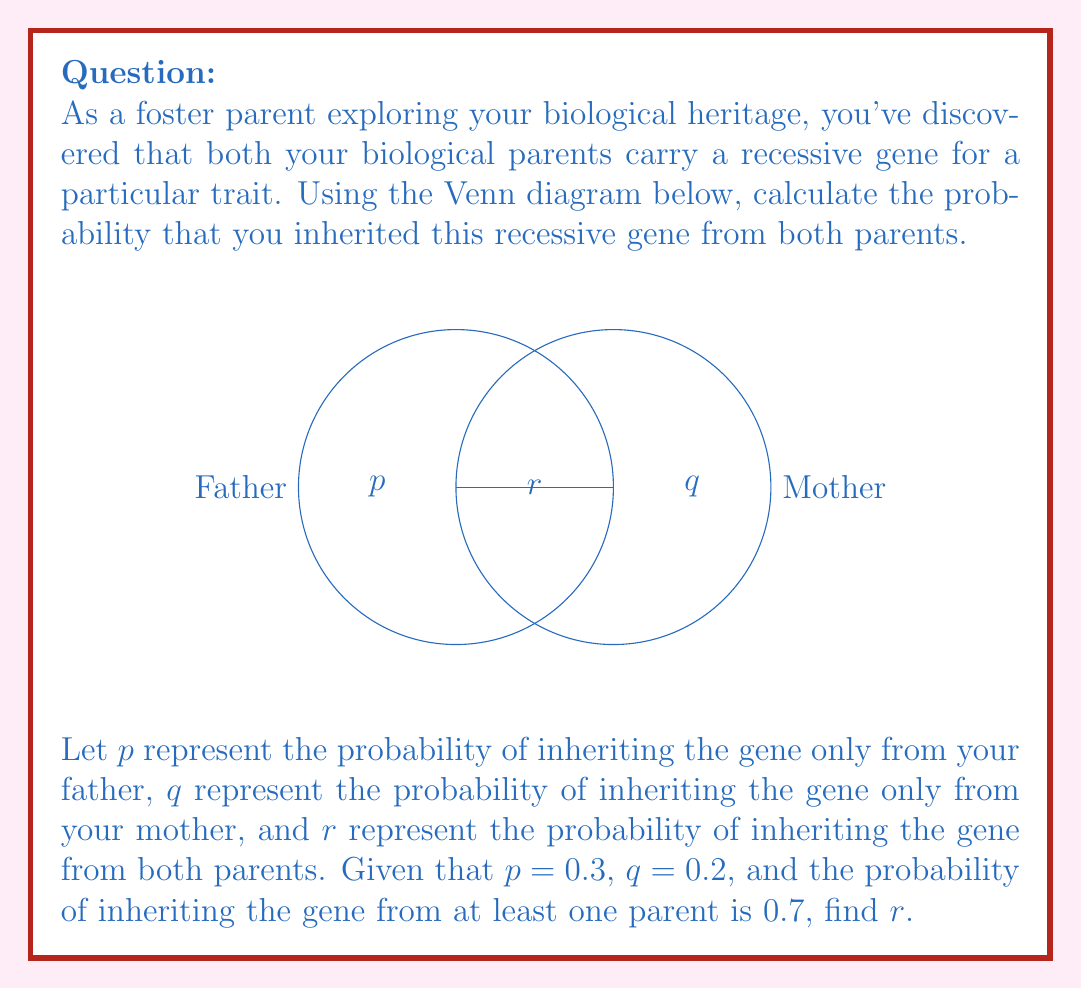Teach me how to tackle this problem. Let's approach this step-by-step:

1) First, we need to understand what the Venn diagram represents. The left circle represents inheriting the gene from the father, and the right circle represents inheriting it from the mother. The overlap ($r$) represents inheriting it from both.

2) We're given:
   $p = 0.3$ (probability of inheriting only from father)
   $q = 0.2$ (probability of inheriting only from mother)
   Probability of inheriting from at least one parent = 0.7

3) In set theory, the probability of inheriting from at least one parent is represented by the union of the two sets:

   $P(\text{Father} \cup \text{Mother}) = p + q + r = 0.7$

4) Substituting the known values:

   $0.3 + 0.2 + r = 0.7$

5) Solving for $r$:

   $r = 0.7 - 0.3 - 0.2 = 0.2$

Therefore, the probability of inheriting the recessive gene from both parents is 0.2 or 20%.
Answer: $r = 0.2$ 